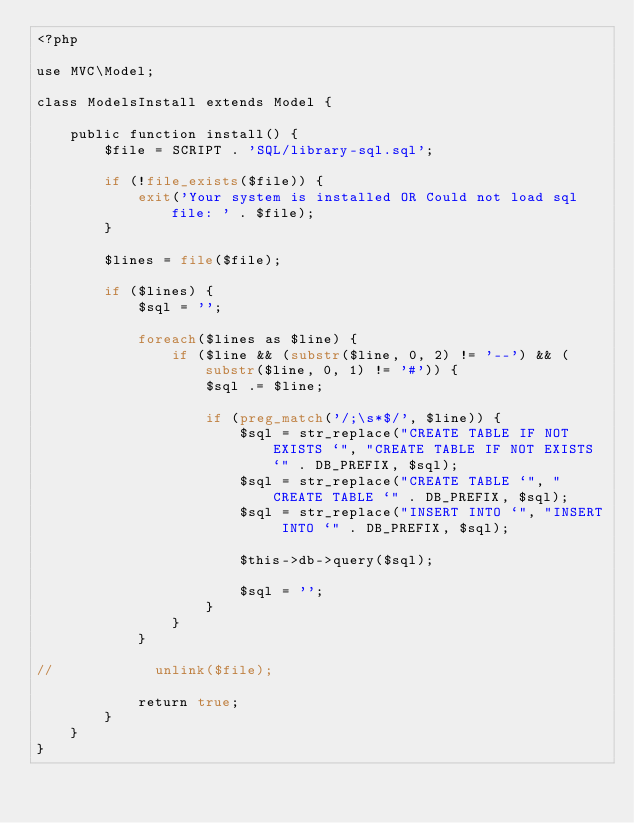Convert code to text. <code><loc_0><loc_0><loc_500><loc_500><_PHP_><?php 

use MVC\Model;

class ModelsInstall extends Model {

    public function install() {
        $file = SCRIPT . 'SQL/library-sql.sql';

        if (!file_exists($file)) {
			exit('Your system is installed OR Could not load sql file: ' . $file);
		}

        $lines = file($file);
        
        if ($lines) {
			$sql = '';

			foreach($lines as $line) {
				if ($line && (substr($line, 0, 2) != '--') && (substr($line, 0, 1) != '#')) {
					$sql .= $line;

					if (preg_match('/;\s*$/', $line)) {
						$sql = str_replace("CREATE TABLE IF NOT EXISTS `", "CREATE TABLE IF NOT EXISTS `" . DB_PREFIX, $sql);
						$sql = str_replace("CREATE TABLE `", "CREATE TABLE `" . DB_PREFIX, $sql);
						$sql = str_replace("INSERT INTO `", "INSERT INTO `" . DB_PREFIX, $sql);

						$this->db->query($sql);

						$sql = '';
					}
				}
            }
            
//            unlink($file);

            return true;
		}
    }
}
</code> 